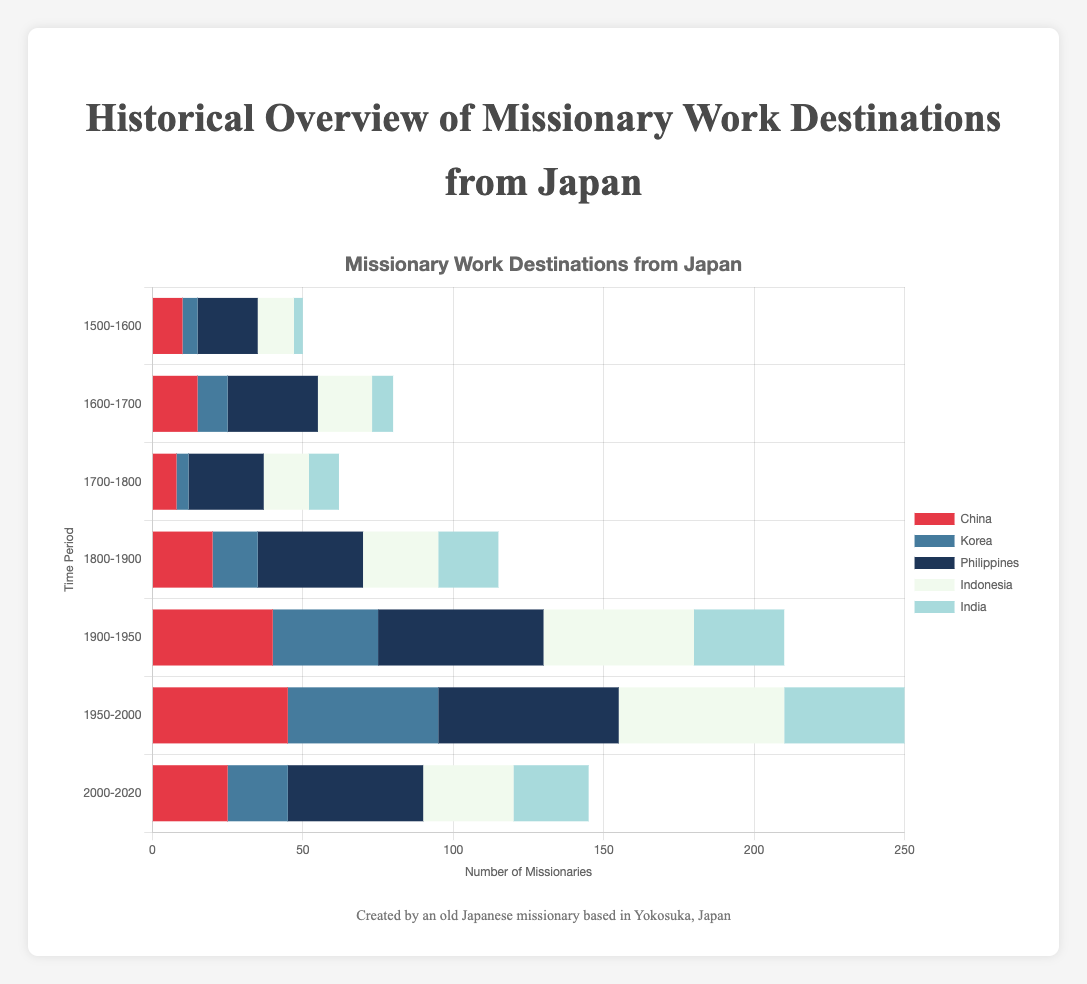What time period had the highest number of missionaries sent to the Philippines? To find this, we look at the bar representing the Philippines in different time periods. The 1950-2000 period has the longest bar, indicating 60 missionaries, which is the highest among all periods.
Answer: 1950-2000 How does the number of missionaries sent to China in 2000-2020 compare to 1900-1950? The chart shows China had 25 missionaries in 2000-2020 and 40 in 1900-1950. Comparing these values, 25 is less than 40.
Answer: 25 is less than 40 Which country had a consistent increase in the number of missionaries from 1500-1600 to 1950-2000? Checking the trend for each country, Philippines is the only destination with a consistent increase over all these periods, starting at 20 and peaking at 60.
Answer: Philippines What is the sum of missionaries sent to Korea and Indonesia during 1800-1900? For Korea: 15; for Indonesia: 25. Adding them gives 15 + 25 = 40.
Answer: 40 How many more missionaries were sent to the Philippines than India in the period of 1800-1900? Philippines had 35 missionaries, while India had 20. The difference is 35 - 20, which equals 15.
Answer: 15 What is the trend in missionary numbers sent to China across all periods? Observing the horizontal bars for China from all periods, there is an overall increase with some fluctuations. Starting from 10, rising to 45, and then a decrease to 25 in the last period.
Answer: Increase with fluctuations Which period had the closest numbers of missionaries sent to China and Indonesia, and what were those numbers? From the periods, 2000-2020 shows China with 25 and Indonesia with 30 missionaries, which are close compared to other periods.
Answer: 2000-2020; China: 25, Indonesia: 30 How did the number of missionaries sent to Indonesia change from 1600-1700 to 2000-2020? Indonesia had 18 missionaries in 1600-1700 and 30 in 2000-2020, indicating an increase of 12 (30 - 18 = 12).
Answer: Increased by 12 In which period was the difference between the highest and lowest numbers of missionaries across all countries the smallest, and what was this difference? Reviewing all periods, 1700-1800 had the smallest difference with 25 (Philippines) - 4 (Korea) = 21.
Answer: 1700-1800; 21 What color represents the bar for India in the chart, and how does the height of this bar for 1950-2000 compare to others? The color representing India is light blue. The bar height for 1950-2000 is 40, which is the highest among other periods for India.
Answer: Light blue; highest for 1950-2000 